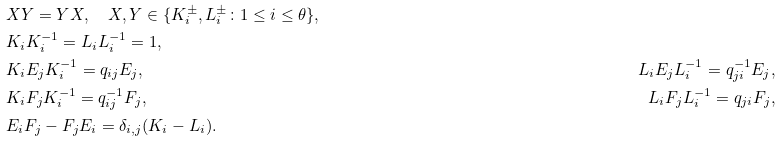<formula> <loc_0><loc_0><loc_500><loc_500>& X Y = Y X , \quad X , Y \in \{ K _ { i } ^ { \pm } , L _ { i } ^ { \pm } \colon 1 \leq i \leq \theta \} , \\ & K _ { i } K _ { i } ^ { - 1 } = L _ { i } L _ { i } ^ { - 1 } = 1 , \\ & K _ { i } E _ { j } K _ { i } ^ { - 1 } = q _ { i j } E _ { j } , \quad & L _ { i } E _ { j } L _ { i } ^ { - 1 } = q _ { j i } ^ { - 1 } E _ { j } , \\ & K _ { i } F _ { j } K _ { i } ^ { - 1 } = q _ { i j } ^ { - 1 } F _ { j } , \quad & L _ { i } F _ { j } L _ { i } ^ { - 1 } = q _ { j i } F _ { j } , \\ & E _ { i } F _ { j } - F _ { j } E _ { i } = \delta _ { i , j } ( K _ { i } - L _ { i } ) .</formula> 